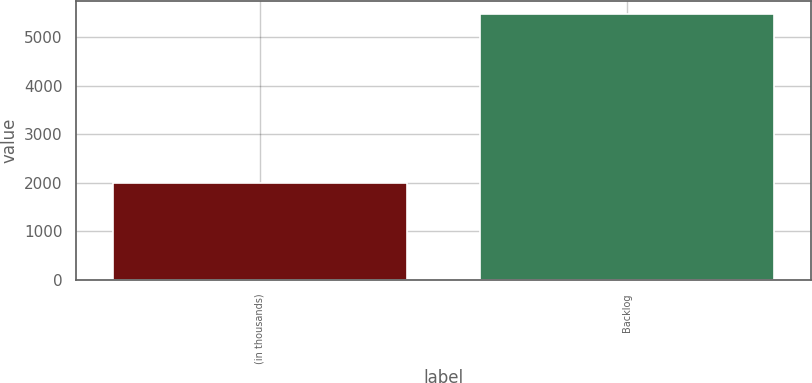Convert chart. <chart><loc_0><loc_0><loc_500><loc_500><bar_chart><fcel>(in thousands)<fcel>Backlog<nl><fcel>2006<fcel>5483<nl></chart> 